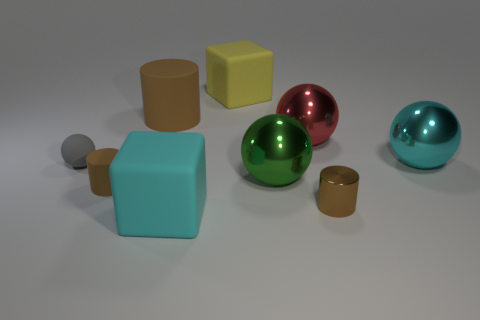How many other things are there of the same color as the big cylinder?
Offer a very short reply. 2. What number of yellow objects are small objects or shiny objects?
Provide a succinct answer. 0. There is a tiny matte thing in front of the small rubber ball; does it have the same shape as the brown object that is to the right of the big brown matte cylinder?
Provide a succinct answer. Yes. How many other things are there of the same material as the large green thing?
Offer a terse response. 3. There is a red metallic object behind the cyan object behind the tiny matte cylinder; are there any green shiny balls that are right of it?
Ensure brevity in your answer.  No. Is the material of the cyan ball the same as the yellow thing?
Offer a terse response. No. Are there any other things that have the same shape as the yellow matte object?
Offer a terse response. Yes. What material is the cyan object to the right of the big matte block that is behind the cyan block?
Make the answer very short. Metal. Are there the same number of tiny matte spheres and tiny green matte cylinders?
Ensure brevity in your answer.  No. How big is the sphere to the right of the tiny shiny thing?
Give a very brief answer. Large. 